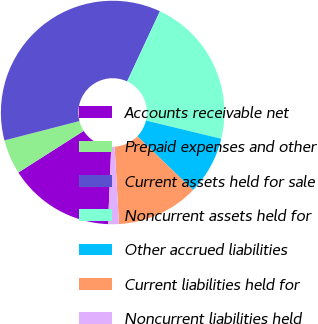Convert chart. <chart><loc_0><loc_0><loc_500><loc_500><pie_chart><fcel>Accounts receivable net<fcel>Prepaid expenses and other<fcel>Current assets held for sale<fcel>Noncurrent assets held for<fcel>Other accrued liabilities<fcel>Current liabilities held for<fcel>Noncurrent liabilities held<nl><fcel>15.33%<fcel>5.0%<fcel>35.98%<fcel>21.82%<fcel>8.44%<fcel>11.88%<fcel>1.56%<nl></chart> 